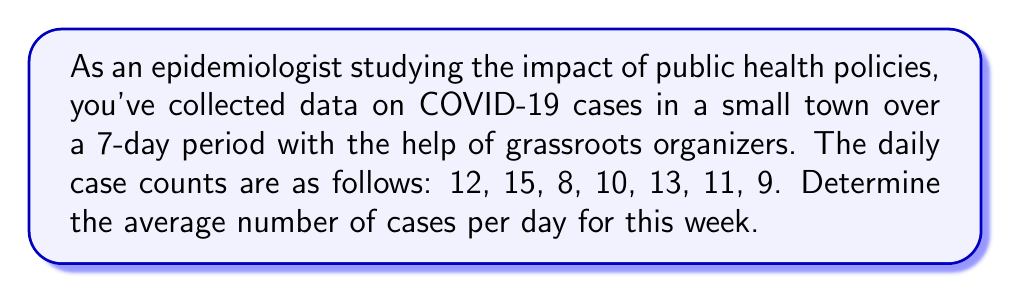Show me your answer to this math problem. To find the average number of cases per day, we need to follow these steps:

1. Sum up all the daily case counts:
   $12 + 15 + 8 + 10 + 13 + 11 + 9 = 78$ total cases

2. Count the number of days:
   There are 7 days in the dataset.

3. Calculate the average by dividing the total cases by the number of days:
   
   $$\text{Average} = \frac{\text{Sum of all values}}{\text{Number of values}}$$

   $$\text{Average} = \frac{78}{7} = 11.14285714$$

4. Round the result to two decimal places:
   $11.14285714 \approx 11.14$ cases per day

Therefore, the average number of COVID-19 cases per day for this week is 11.14.
Answer: $11.14$ cases per day 